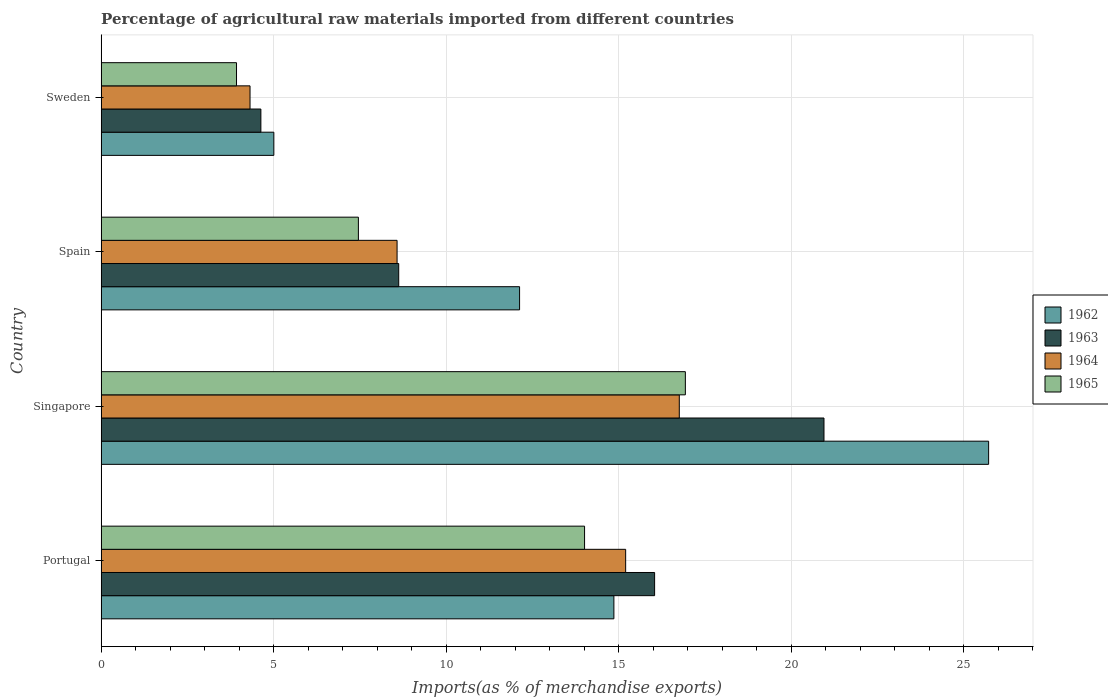How many groups of bars are there?
Make the answer very short. 4. Are the number of bars on each tick of the Y-axis equal?
Your response must be concise. Yes. How many bars are there on the 2nd tick from the top?
Provide a succinct answer. 4. How many bars are there on the 1st tick from the bottom?
Offer a very short reply. 4. In how many cases, is the number of bars for a given country not equal to the number of legend labels?
Keep it short and to the point. 0. What is the percentage of imports to different countries in 1962 in Spain?
Provide a succinct answer. 12.13. Across all countries, what is the maximum percentage of imports to different countries in 1964?
Your response must be concise. 16.76. Across all countries, what is the minimum percentage of imports to different countries in 1962?
Offer a very short reply. 5.01. In which country was the percentage of imports to different countries in 1965 maximum?
Provide a short and direct response. Singapore. In which country was the percentage of imports to different countries in 1964 minimum?
Your answer should be very brief. Sweden. What is the total percentage of imports to different countries in 1965 in the graph?
Your response must be concise. 42.33. What is the difference between the percentage of imports to different countries in 1962 in Spain and that in Sweden?
Make the answer very short. 7.12. What is the difference between the percentage of imports to different countries in 1964 in Sweden and the percentage of imports to different countries in 1962 in Singapore?
Offer a terse response. -21.41. What is the average percentage of imports to different countries in 1962 per country?
Offer a very short reply. 14.43. What is the difference between the percentage of imports to different countries in 1965 and percentage of imports to different countries in 1964 in Sweden?
Keep it short and to the point. -0.39. In how many countries, is the percentage of imports to different countries in 1962 greater than 24 %?
Provide a succinct answer. 1. What is the ratio of the percentage of imports to different countries in 1963 in Portugal to that in Sweden?
Keep it short and to the point. 3.46. Is the percentage of imports to different countries in 1963 in Singapore less than that in Sweden?
Provide a short and direct response. No. What is the difference between the highest and the second highest percentage of imports to different countries in 1964?
Provide a succinct answer. 1.55. What is the difference between the highest and the lowest percentage of imports to different countries in 1964?
Give a very brief answer. 12.44. Is the sum of the percentage of imports to different countries in 1963 in Spain and Sweden greater than the maximum percentage of imports to different countries in 1964 across all countries?
Provide a succinct answer. No. Is it the case that in every country, the sum of the percentage of imports to different countries in 1965 and percentage of imports to different countries in 1963 is greater than the sum of percentage of imports to different countries in 1962 and percentage of imports to different countries in 1964?
Offer a very short reply. No. What does the 2nd bar from the top in Singapore represents?
Offer a very short reply. 1964. How many countries are there in the graph?
Offer a very short reply. 4. Are the values on the major ticks of X-axis written in scientific E-notation?
Give a very brief answer. No. Does the graph contain grids?
Your response must be concise. Yes. How are the legend labels stacked?
Your answer should be very brief. Vertical. What is the title of the graph?
Ensure brevity in your answer.  Percentage of agricultural raw materials imported from different countries. Does "2002" appear as one of the legend labels in the graph?
Make the answer very short. No. What is the label or title of the X-axis?
Your answer should be very brief. Imports(as % of merchandise exports). What is the label or title of the Y-axis?
Keep it short and to the point. Country. What is the Imports(as % of merchandise exports) of 1962 in Portugal?
Your answer should be compact. 14.86. What is the Imports(as % of merchandise exports) in 1963 in Portugal?
Your answer should be compact. 16.04. What is the Imports(as % of merchandise exports) of 1964 in Portugal?
Give a very brief answer. 15.2. What is the Imports(as % of merchandise exports) of 1965 in Portugal?
Your response must be concise. 14.01. What is the Imports(as % of merchandise exports) of 1962 in Singapore?
Your response must be concise. 25.73. What is the Imports(as % of merchandise exports) of 1963 in Singapore?
Ensure brevity in your answer.  20.95. What is the Imports(as % of merchandise exports) of 1964 in Singapore?
Your answer should be compact. 16.76. What is the Imports(as % of merchandise exports) of 1965 in Singapore?
Give a very brief answer. 16.93. What is the Imports(as % of merchandise exports) in 1962 in Spain?
Provide a succinct answer. 12.13. What is the Imports(as % of merchandise exports) in 1963 in Spain?
Your answer should be compact. 8.63. What is the Imports(as % of merchandise exports) in 1964 in Spain?
Offer a terse response. 8.58. What is the Imports(as % of merchandise exports) in 1965 in Spain?
Your response must be concise. 7.46. What is the Imports(as % of merchandise exports) of 1962 in Sweden?
Make the answer very short. 5.01. What is the Imports(as % of merchandise exports) of 1963 in Sweden?
Your answer should be very brief. 4.63. What is the Imports(as % of merchandise exports) of 1964 in Sweden?
Provide a succinct answer. 4.32. What is the Imports(as % of merchandise exports) of 1965 in Sweden?
Offer a very short reply. 3.92. Across all countries, what is the maximum Imports(as % of merchandise exports) of 1962?
Your answer should be very brief. 25.73. Across all countries, what is the maximum Imports(as % of merchandise exports) of 1963?
Provide a short and direct response. 20.95. Across all countries, what is the maximum Imports(as % of merchandise exports) in 1964?
Make the answer very short. 16.76. Across all countries, what is the maximum Imports(as % of merchandise exports) of 1965?
Give a very brief answer. 16.93. Across all countries, what is the minimum Imports(as % of merchandise exports) of 1962?
Offer a very short reply. 5.01. Across all countries, what is the minimum Imports(as % of merchandise exports) of 1963?
Ensure brevity in your answer.  4.63. Across all countries, what is the minimum Imports(as % of merchandise exports) of 1964?
Offer a terse response. 4.32. Across all countries, what is the minimum Imports(as % of merchandise exports) of 1965?
Offer a very short reply. 3.92. What is the total Imports(as % of merchandise exports) of 1962 in the graph?
Provide a short and direct response. 57.72. What is the total Imports(as % of merchandise exports) of 1963 in the graph?
Make the answer very short. 50.25. What is the total Imports(as % of merchandise exports) of 1964 in the graph?
Make the answer very short. 44.86. What is the total Imports(as % of merchandise exports) in 1965 in the graph?
Make the answer very short. 42.33. What is the difference between the Imports(as % of merchandise exports) of 1962 in Portugal and that in Singapore?
Provide a succinct answer. -10.86. What is the difference between the Imports(as % of merchandise exports) of 1963 in Portugal and that in Singapore?
Ensure brevity in your answer.  -4.91. What is the difference between the Imports(as % of merchandise exports) of 1964 in Portugal and that in Singapore?
Provide a short and direct response. -1.55. What is the difference between the Imports(as % of merchandise exports) in 1965 in Portugal and that in Singapore?
Offer a terse response. -2.92. What is the difference between the Imports(as % of merchandise exports) in 1962 in Portugal and that in Spain?
Keep it short and to the point. 2.73. What is the difference between the Imports(as % of merchandise exports) of 1963 in Portugal and that in Spain?
Your answer should be very brief. 7.42. What is the difference between the Imports(as % of merchandise exports) in 1964 in Portugal and that in Spain?
Provide a succinct answer. 6.63. What is the difference between the Imports(as % of merchandise exports) in 1965 in Portugal and that in Spain?
Keep it short and to the point. 6.56. What is the difference between the Imports(as % of merchandise exports) in 1962 in Portugal and that in Sweden?
Your answer should be compact. 9.86. What is the difference between the Imports(as % of merchandise exports) of 1963 in Portugal and that in Sweden?
Make the answer very short. 11.41. What is the difference between the Imports(as % of merchandise exports) in 1964 in Portugal and that in Sweden?
Give a very brief answer. 10.89. What is the difference between the Imports(as % of merchandise exports) of 1965 in Portugal and that in Sweden?
Ensure brevity in your answer.  10.09. What is the difference between the Imports(as % of merchandise exports) in 1962 in Singapore and that in Spain?
Your answer should be compact. 13.6. What is the difference between the Imports(as % of merchandise exports) of 1963 in Singapore and that in Spain?
Your answer should be compact. 12.33. What is the difference between the Imports(as % of merchandise exports) in 1964 in Singapore and that in Spain?
Provide a short and direct response. 8.18. What is the difference between the Imports(as % of merchandise exports) in 1965 in Singapore and that in Spain?
Provide a short and direct response. 9.48. What is the difference between the Imports(as % of merchandise exports) of 1962 in Singapore and that in Sweden?
Provide a succinct answer. 20.72. What is the difference between the Imports(as % of merchandise exports) of 1963 in Singapore and that in Sweden?
Give a very brief answer. 16.32. What is the difference between the Imports(as % of merchandise exports) in 1964 in Singapore and that in Sweden?
Your answer should be very brief. 12.44. What is the difference between the Imports(as % of merchandise exports) of 1965 in Singapore and that in Sweden?
Your answer should be very brief. 13.01. What is the difference between the Imports(as % of merchandise exports) in 1962 in Spain and that in Sweden?
Keep it short and to the point. 7.12. What is the difference between the Imports(as % of merchandise exports) in 1963 in Spain and that in Sweden?
Offer a terse response. 4. What is the difference between the Imports(as % of merchandise exports) of 1964 in Spain and that in Sweden?
Your answer should be very brief. 4.26. What is the difference between the Imports(as % of merchandise exports) in 1965 in Spain and that in Sweden?
Your answer should be very brief. 3.53. What is the difference between the Imports(as % of merchandise exports) in 1962 in Portugal and the Imports(as % of merchandise exports) in 1963 in Singapore?
Your answer should be very brief. -6.09. What is the difference between the Imports(as % of merchandise exports) in 1962 in Portugal and the Imports(as % of merchandise exports) in 1964 in Singapore?
Offer a very short reply. -1.9. What is the difference between the Imports(as % of merchandise exports) of 1962 in Portugal and the Imports(as % of merchandise exports) of 1965 in Singapore?
Keep it short and to the point. -2.07. What is the difference between the Imports(as % of merchandise exports) of 1963 in Portugal and the Imports(as % of merchandise exports) of 1964 in Singapore?
Your answer should be very brief. -0.72. What is the difference between the Imports(as % of merchandise exports) in 1963 in Portugal and the Imports(as % of merchandise exports) in 1965 in Singapore?
Your answer should be compact. -0.89. What is the difference between the Imports(as % of merchandise exports) of 1964 in Portugal and the Imports(as % of merchandise exports) of 1965 in Singapore?
Your answer should be very brief. -1.73. What is the difference between the Imports(as % of merchandise exports) of 1962 in Portugal and the Imports(as % of merchandise exports) of 1963 in Spain?
Your answer should be compact. 6.24. What is the difference between the Imports(as % of merchandise exports) of 1962 in Portugal and the Imports(as % of merchandise exports) of 1964 in Spain?
Offer a terse response. 6.28. What is the difference between the Imports(as % of merchandise exports) in 1962 in Portugal and the Imports(as % of merchandise exports) in 1965 in Spain?
Your answer should be compact. 7.41. What is the difference between the Imports(as % of merchandise exports) of 1963 in Portugal and the Imports(as % of merchandise exports) of 1964 in Spain?
Offer a very short reply. 7.47. What is the difference between the Imports(as % of merchandise exports) in 1963 in Portugal and the Imports(as % of merchandise exports) in 1965 in Spain?
Your answer should be compact. 8.59. What is the difference between the Imports(as % of merchandise exports) in 1964 in Portugal and the Imports(as % of merchandise exports) in 1965 in Spain?
Make the answer very short. 7.75. What is the difference between the Imports(as % of merchandise exports) in 1962 in Portugal and the Imports(as % of merchandise exports) in 1963 in Sweden?
Ensure brevity in your answer.  10.23. What is the difference between the Imports(as % of merchandise exports) of 1962 in Portugal and the Imports(as % of merchandise exports) of 1964 in Sweden?
Keep it short and to the point. 10.55. What is the difference between the Imports(as % of merchandise exports) in 1962 in Portugal and the Imports(as % of merchandise exports) in 1965 in Sweden?
Ensure brevity in your answer.  10.94. What is the difference between the Imports(as % of merchandise exports) of 1963 in Portugal and the Imports(as % of merchandise exports) of 1964 in Sweden?
Your answer should be compact. 11.73. What is the difference between the Imports(as % of merchandise exports) of 1963 in Portugal and the Imports(as % of merchandise exports) of 1965 in Sweden?
Your answer should be compact. 12.12. What is the difference between the Imports(as % of merchandise exports) in 1964 in Portugal and the Imports(as % of merchandise exports) in 1965 in Sweden?
Make the answer very short. 11.28. What is the difference between the Imports(as % of merchandise exports) in 1962 in Singapore and the Imports(as % of merchandise exports) in 1963 in Spain?
Give a very brief answer. 17.1. What is the difference between the Imports(as % of merchandise exports) in 1962 in Singapore and the Imports(as % of merchandise exports) in 1964 in Spain?
Provide a succinct answer. 17.15. What is the difference between the Imports(as % of merchandise exports) in 1962 in Singapore and the Imports(as % of merchandise exports) in 1965 in Spain?
Your response must be concise. 18.27. What is the difference between the Imports(as % of merchandise exports) in 1963 in Singapore and the Imports(as % of merchandise exports) in 1964 in Spain?
Your response must be concise. 12.38. What is the difference between the Imports(as % of merchandise exports) in 1963 in Singapore and the Imports(as % of merchandise exports) in 1965 in Spain?
Your response must be concise. 13.5. What is the difference between the Imports(as % of merchandise exports) in 1964 in Singapore and the Imports(as % of merchandise exports) in 1965 in Spain?
Your answer should be very brief. 9.3. What is the difference between the Imports(as % of merchandise exports) in 1962 in Singapore and the Imports(as % of merchandise exports) in 1963 in Sweden?
Provide a short and direct response. 21.09. What is the difference between the Imports(as % of merchandise exports) of 1962 in Singapore and the Imports(as % of merchandise exports) of 1964 in Sweden?
Ensure brevity in your answer.  21.41. What is the difference between the Imports(as % of merchandise exports) of 1962 in Singapore and the Imports(as % of merchandise exports) of 1965 in Sweden?
Your answer should be very brief. 21.8. What is the difference between the Imports(as % of merchandise exports) in 1963 in Singapore and the Imports(as % of merchandise exports) in 1964 in Sweden?
Give a very brief answer. 16.64. What is the difference between the Imports(as % of merchandise exports) of 1963 in Singapore and the Imports(as % of merchandise exports) of 1965 in Sweden?
Keep it short and to the point. 17.03. What is the difference between the Imports(as % of merchandise exports) in 1964 in Singapore and the Imports(as % of merchandise exports) in 1965 in Sweden?
Offer a terse response. 12.83. What is the difference between the Imports(as % of merchandise exports) of 1962 in Spain and the Imports(as % of merchandise exports) of 1963 in Sweden?
Offer a very short reply. 7.5. What is the difference between the Imports(as % of merchandise exports) of 1962 in Spain and the Imports(as % of merchandise exports) of 1964 in Sweden?
Your answer should be compact. 7.81. What is the difference between the Imports(as % of merchandise exports) in 1962 in Spain and the Imports(as % of merchandise exports) in 1965 in Sweden?
Make the answer very short. 8.21. What is the difference between the Imports(as % of merchandise exports) of 1963 in Spain and the Imports(as % of merchandise exports) of 1964 in Sweden?
Your answer should be compact. 4.31. What is the difference between the Imports(as % of merchandise exports) in 1963 in Spain and the Imports(as % of merchandise exports) in 1965 in Sweden?
Your answer should be compact. 4.7. What is the difference between the Imports(as % of merchandise exports) in 1964 in Spain and the Imports(as % of merchandise exports) in 1965 in Sweden?
Your answer should be very brief. 4.65. What is the average Imports(as % of merchandise exports) in 1962 per country?
Provide a succinct answer. 14.43. What is the average Imports(as % of merchandise exports) of 1963 per country?
Keep it short and to the point. 12.56. What is the average Imports(as % of merchandise exports) of 1964 per country?
Keep it short and to the point. 11.21. What is the average Imports(as % of merchandise exports) of 1965 per country?
Your answer should be compact. 10.58. What is the difference between the Imports(as % of merchandise exports) of 1962 and Imports(as % of merchandise exports) of 1963 in Portugal?
Ensure brevity in your answer.  -1.18. What is the difference between the Imports(as % of merchandise exports) in 1962 and Imports(as % of merchandise exports) in 1964 in Portugal?
Your answer should be compact. -0.34. What is the difference between the Imports(as % of merchandise exports) in 1962 and Imports(as % of merchandise exports) in 1965 in Portugal?
Give a very brief answer. 0.85. What is the difference between the Imports(as % of merchandise exports) of 1963 and Imports(as % of merchandise exports) of 1964 in Portugal?
Ensure brevity in your answer.  0.84. What is the difference between the Imports(as % of merchandise exports) in 1963 and Imports(as % of merchandise exports) in 1965 in Portugal?
Your answer should be compact. 2.03. What is the difference between the Imports(as % of merchandise exports) of 1964 and Imports(as % of merchandise exports) of 1965 in Portugal?
Your answer should be compact. 1.19. What is the difference between the Imports(as % of merchandise exports) in 1962 and Imports(as % of merchandise exports) in 1963 in Singapore?
Your answer should be compact. 4.77. What is the difference between the Imports(as % of merchandise exports) of 1962 and Imports(as % of merchandise exports) of 1964 in Singapore?
Offer a very short reply. 8.97. What is the difference between the Imports(as % of merchandise exports) of 1962 and Imports(as % of merchandise exports) of 1965 in Singapore?
Make the answer very short. 8.79. What is the difference between the Imports(as % of merchandise exports) of 1963 and Imports(as % of merchandise exports) of 1964 in Singapore?
Provide a succinct answer. 4.19. What is the difference between the Imports(as % of merchandise exports) of 1963 and Imports(as % of merchandise exports) of 1965 in Singapore?
Keep it short and to the point. 4.02. What is the difference between the Imports(as % of merchandise exports) in 1964 and Imports(as % of merchandise exports) in 1965 in Singapore?
Provide a short and direct response. -0.18. What is the difference between the Imports(as % of merchandise exports) of 1962 and Imports(as % of merchandise exports) of 1963 in Spain?
Your answer should be very brief. 3.5. What is the difference between the Imports(as % of merchandise exports) in 1962 and Imports(as % of merchandise exports) in 1964 in Spain?
Your answer should be compact. 3.55. What is the difference between the Imports(as % of merchandise exports) in 1962 and Imports(as % of merchandise exports) in 1965 in Spain?
Give a very brief answer. 4.67. What is the difference between the Imports(as % of merchandise exports) in 1963 and Imports(as % of merchandise exports) in 1964 in Spain?
Keep it short and to the point. 0.05. What is the difference between the Imports(as % of merchandise exports) of 1963 and Imports(as % of merchandise exports) of 1965 in Spain?
Keep it short and to the point. 1.17. What is the difference between the Imports(as % of merchandise exports) of 1964 and Imports(as % of merchandise exports) of 1965 in Spain?
Keep it short and to the point. 1.12. What is the difference between the Imports(as % of merchandise exports) in 1962 and Imports(as % of merchandise exports) in 1963 in Sweden?
Ensure brevity in your answer.  0.38. What is the difference between the Imports(as % of merchandise exports) of 1962 and Imports(as % of merchandise exports) of 1964 in Sweden?
Provide a short and direct response. 0.69. What is the difference between the Imports(as % of merchandise exports) of 1962 and Imports(as % of merchandise exports) of 1965 in Sweden?
Make the answer very short. 1.08. What is the difference between the Imports(as % of merchandise exports) in 1963 and Imports(as % of merchandise exports) in 1964 in Sweden?
Make the answer very short. 0.31. What is the difference between the Imports(as % of merchandise exports) of 1963 and Imports(as % of merchandise exports) of 1965 in Sweden?
Provide a succinct answer. 0.71. What is the difference between the Imports(as % of merchandise exports) of 1964 and Imports(as % of merchandise exports) of 1965 in Sweden?
Offer a terse response. 0.39. What is the ratio of the Imports(as % of merchandise exports) of 1962 in Portugal to that in Singapore?
Provide a short and direct response. 0.58. What is the ratio of the Imports(as % of merchandise exports) of 1963 in Portugal to that in Singapore?
Keep it short and to the point. 0.77. What is the ratio of the Imports(as % of merchandise exports) of 1964 in Portugal to that in Singapore?
Offer a terse response. 0.91. What is the ratio of the Imports(as % of merchandise exports) of 1965 in Portugal to that in Singapore?
Make the answer very short. 0.83. What is the ratio of the Imports(as % of merchandise exports) in 1962 in Portugal to that in Spain?
Your answer should be very brief. 1.23. What is the ratio of the Imports(as % of merchandise exports) of 1963 in Portugal to that in Spain?
Provide a succinct answer. 1.86. What is the ratio of the Imports(as % of merchandise exports) of 1964 in Portugal to that in Spain?
Your answer should be compact. 1.77. What is the ratio of the Imports(as % of merchandise exports) in 1965 in Portugal to that in Spain?
Offer a terse response. 1.88. What is the ratio of the Imports(as % of merchandise exports) of 1962 in Portugal to that in Sweden?
Make the answer very short. 2.97. What is the ratio of the Imports(as % of merchandise exports) of 1963 in Portugal to that in Sweden?
Give a very brief answer. 3.46. What is the ratio of the Imports(as % of merchandise exports) of 1964 in Portugal to that in Sweden?
Offer a terse response. 3.52. What is the ratio of the Imports(as % of merchandise exports) of 1965 in Portugal to that in Sweden?
Keep it short and to the point. 3.57. What is the ratio of the Imports(as % of merchandise exports) in 1962 in Singapore to that in Spain?
Your response must be concise. 2.12. What is the ratio of the Imports(as % of merchandise exports) of 1963 in Singapore to that in Spain?
Your answer should be very brief. 2.43. What is the ratio of the Imports(as % of merchandise exports) in 1964 in Singapore to that in Spain?
Provide a succinct answer. 1.95. What is the ratio of the Imports(as % of merchandise exports) of 1965 in Singapore to that in Spain?
Give a very brief answer. 2.27. What is the ratio of the Imports(as % of merchandise exports) in 1962 in Singapore to that in Sweden?
Make the answer very short. 5.14. What is the ratio of the Imports(as % of merchandise exports) in 1963 in Singapore to that in Sweden?
Provide a succinct answer. 4.53. What is the ratio of the Imports(as % of merchandise exports) in 1964 in Singapore to that in Sweden?
Your response must be concise. 3.88. What is the ratio of the Imports(as % of merchandise exports) in 1965 in Singapore to that in Sweden?
Give a very brief answer. 4.32. What is the ratio of the Imports(as % of merchandise exports) of 1962 in Spain to that in Sweden?
Your answer should be very brief. 2.42. What is the ratio of the Imports(as % of merchandise exports) of 1963 in Spain to that in Sweden?
Offer a very short reply. 1.86. What is the ratio of the Imports(as % of merchandise exports) of 1964 in Spain to that in Sweden?
Provide a succinct answer. 1.99. What is the ratio of the Imports(as % of merchandise exports) of 1965 in Spain to that in Sweden?
Provide a short and direct response. 1.9. What is the difference between the highest and the second highest Imports(as % of merchandise exports) of 1962?
Ensure brevity in your answer.  10.86. What is the difference between the highest and the second highest Imports(as % of merchandise exports) of 1963?
Offer a very short reply. 4.91. What is the difference between the highest and the second highest Imports(as % of merchandise exports) in 1964?
Your answer should be very brief. 1.55. What is the difference between the highest and the second highest Imports(as % of merchandise exports) of 1965?
Your answer should be very brief. 2.92. What is the difference between the highest and the lowest Imports(as % of merchandise exports) of 1962?
Make the answer very short. 20.72. What is the difference between the highest and the lowest Imports(as % of merchandise exports) in 1963?
Make the answer very short. 16.32. What is the difference between the highest and the lowest Imports(as % of merchandise exports) of 1964?
Keep it short and to the point. 12.44. What is the difference between the highest and the lowest Imports(as % of merchandise exports) of 1965?
Your answer should be very brief. 13.01. 